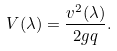Convert formula to latex. <formula><loc_0><loc_0><loc_500><loc_500>V ( \lambda ) = \frac { v ^ { 2 } ( \lambda ) } { 2 g q } .</formula> 